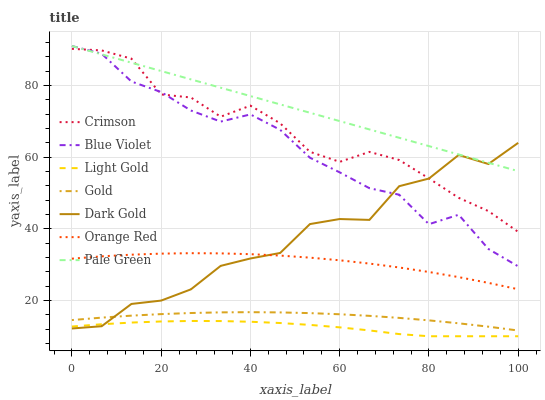Does Light Gold have the minimum area under the curve?
Answer yes or no. Yes. Does Pale Green have the maximum area under the curve?
Answer yes or no. Yes. Does Dark Gold have the minimum area under the curve?
Answer yes or no. No. Does Dark Gold have the maximum area under the curve?
Answer yes or no. No. Is Pale Green the smoothest?
Answer yes or no. Yes. Is Dark Gold the roughest?
Answer yes or no. Yes. Is Dark Gold the smoothest?
Answer yes or no. No. Is Pale Green the roughest?
Answer yes or no. No. Does Light Gold have the lowest value?
Answer yes or no. Yes. Does Dark Gold have the lowest value?
Answer yes or no. No. Does Blue Violet have the highest value?
Answer yes or no. Yes. Does Dark Gold have the highest value?
Answer yes or no. No. Is Orange Red less than Blue Violet?
Answer yes or no. Yes. Is Crimson greater than Orange Red?
Answer yes or no. Yes. Does Pale Green intersect Dark Gold?
Answer yes or no. Yes. Is Pale Green less than Dark Gold?
Answer yes or no. No. Is Pale Green greater than Dark Gold?
Answer yes or no. No. Does Orange Red intersect Blue Violet?
Answer yes or no. No. 